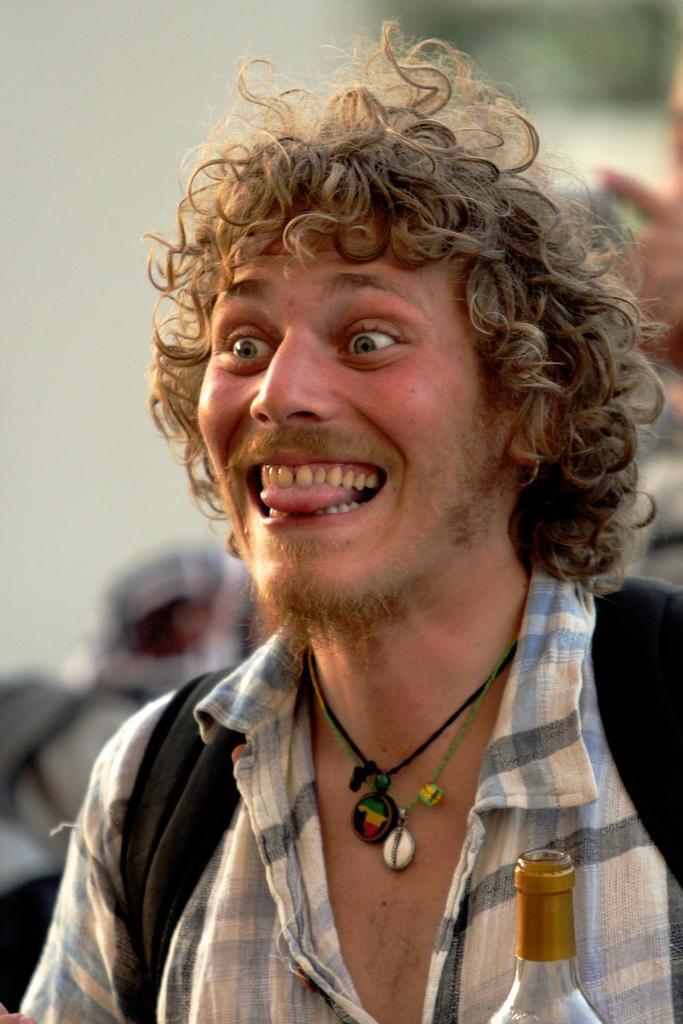How would you summarize this image in a sentence or two? There is a person wearing a bag and black thread with locket on the neck is smiling. In the front there is a bottle. And in the background it is blurred. 